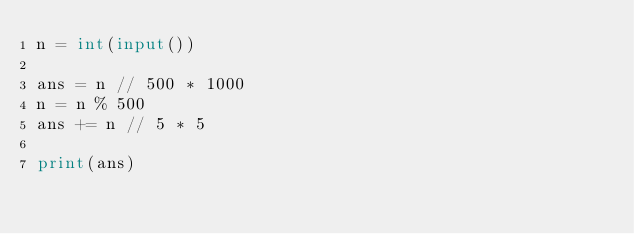Convert code to text. <code><loc_0><loc_0><loc_500><loc_500><_Python_>n = int(input())

ans = n // 500 * 1000
n = n % 500
ans += n // 5 * 5

print(ans)
</code> 